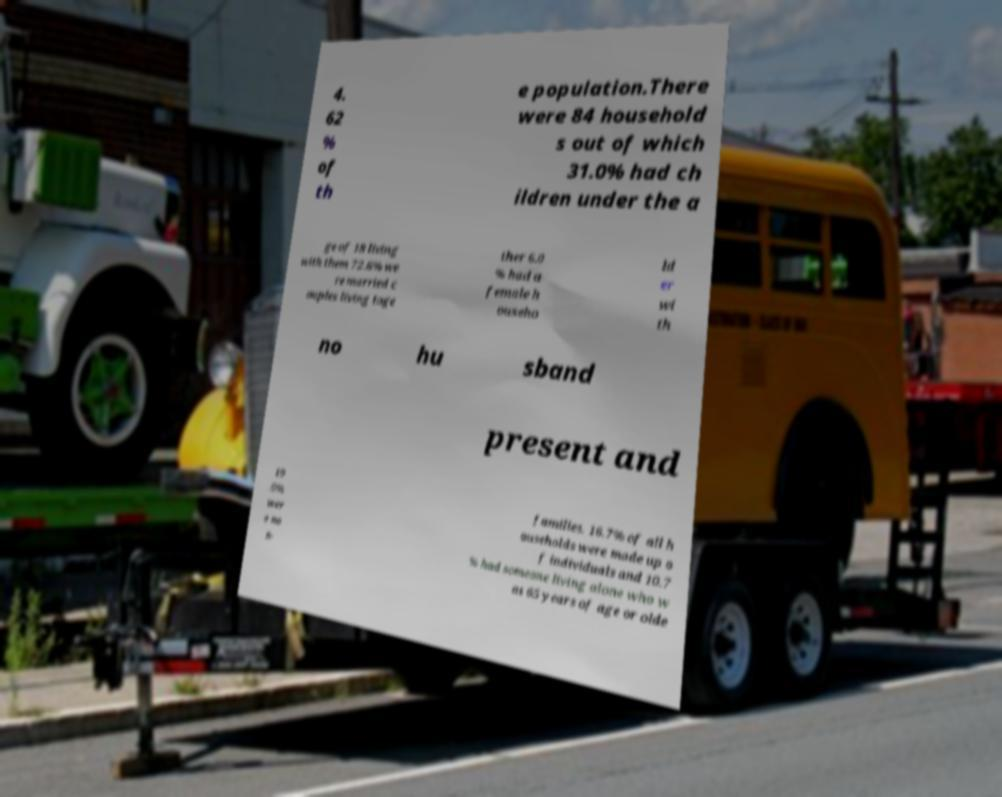Please identify and transcribe the text found in this image. 4. 62 % of th e population.There were 84 household s out of which 31.0% had ch ildren under the a ge of 18 living with them 72.6% we re married c ouples living toge ther 6.0 % had a female h ouseho ld er wi th no hu sband present and 19 .0% wer e no n- families. 16.7% of all h ouseholds were made up o f individuals and 10.7 % had someone living alone who w as 65 years of age or olde 